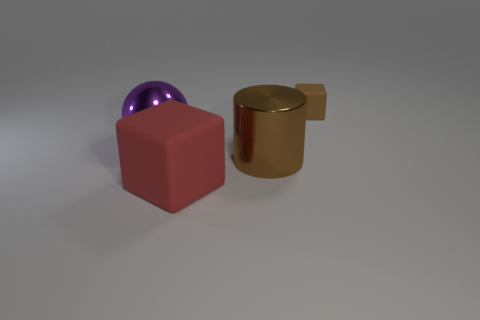How many other things are there of the same size as the brown matte object?
Keep it short and to the point. 0. Is there a big brown cylinder left of the brown thing that is in front of the rubber thing that is to the right of the large brown cylinder?
Offer a terse response. No. Are the brown object that is in front of the tiny brown rubber cube and the big purple object made of the same material?
Your answer should be very brief. Yes. The other matte object that is the same shape as the large rubber thing is what color?
Offer a terse response. Brown. Is there any other thing that has the same shape as the big purple thing?
Offer a very short reply. No. Are there an equal number of small things on the left side of the large shiny cylinder and big brown shiny objects?
Keep it short and to the point. No. Are there any blocks in front of the purple shiny sphere?
Offer a terse response. Yes. What is the size of the rubber block on the left side of the matte cube behind the rubber thing in front of the big sphere?
Give a very brief answer. Large. Do the rubber object left of the tiny brown matte thing and the brown object behind the large purple metal thing have the same shape?
Your answer should be compact. Yes. What is the size of the other matte thing that is the same shape as the big red object?
Offer a terse response. Small. 